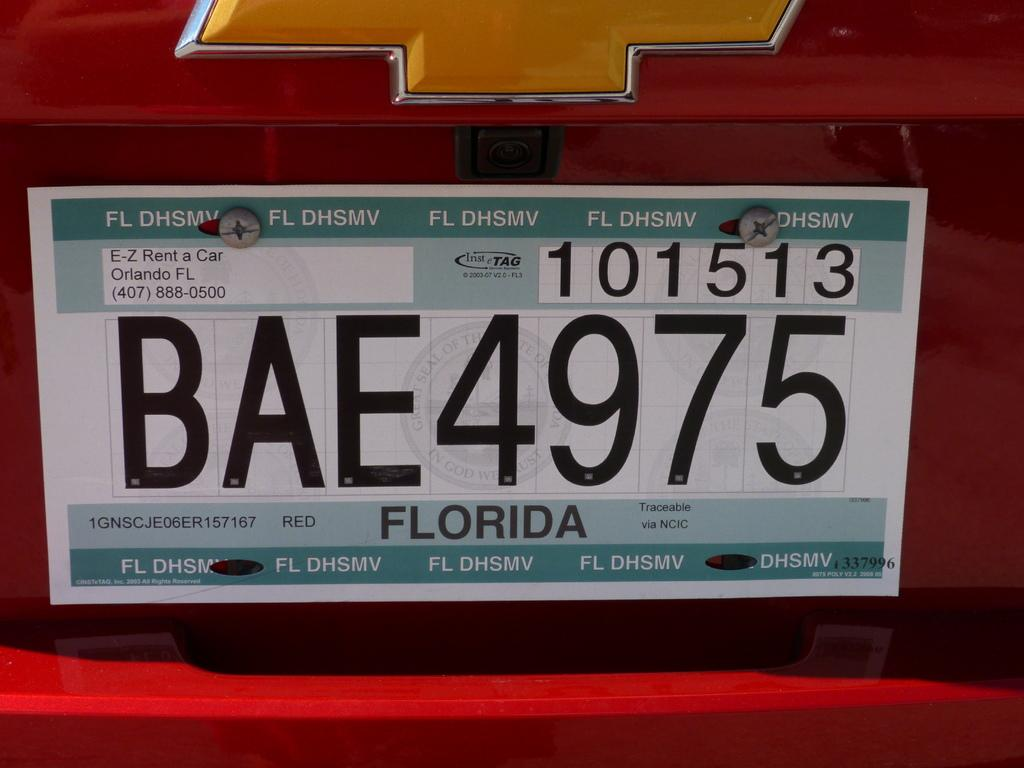<image>
Give a short and clear explanation of the subsequent image. A red Chevy has a the license plate BAE4975. 